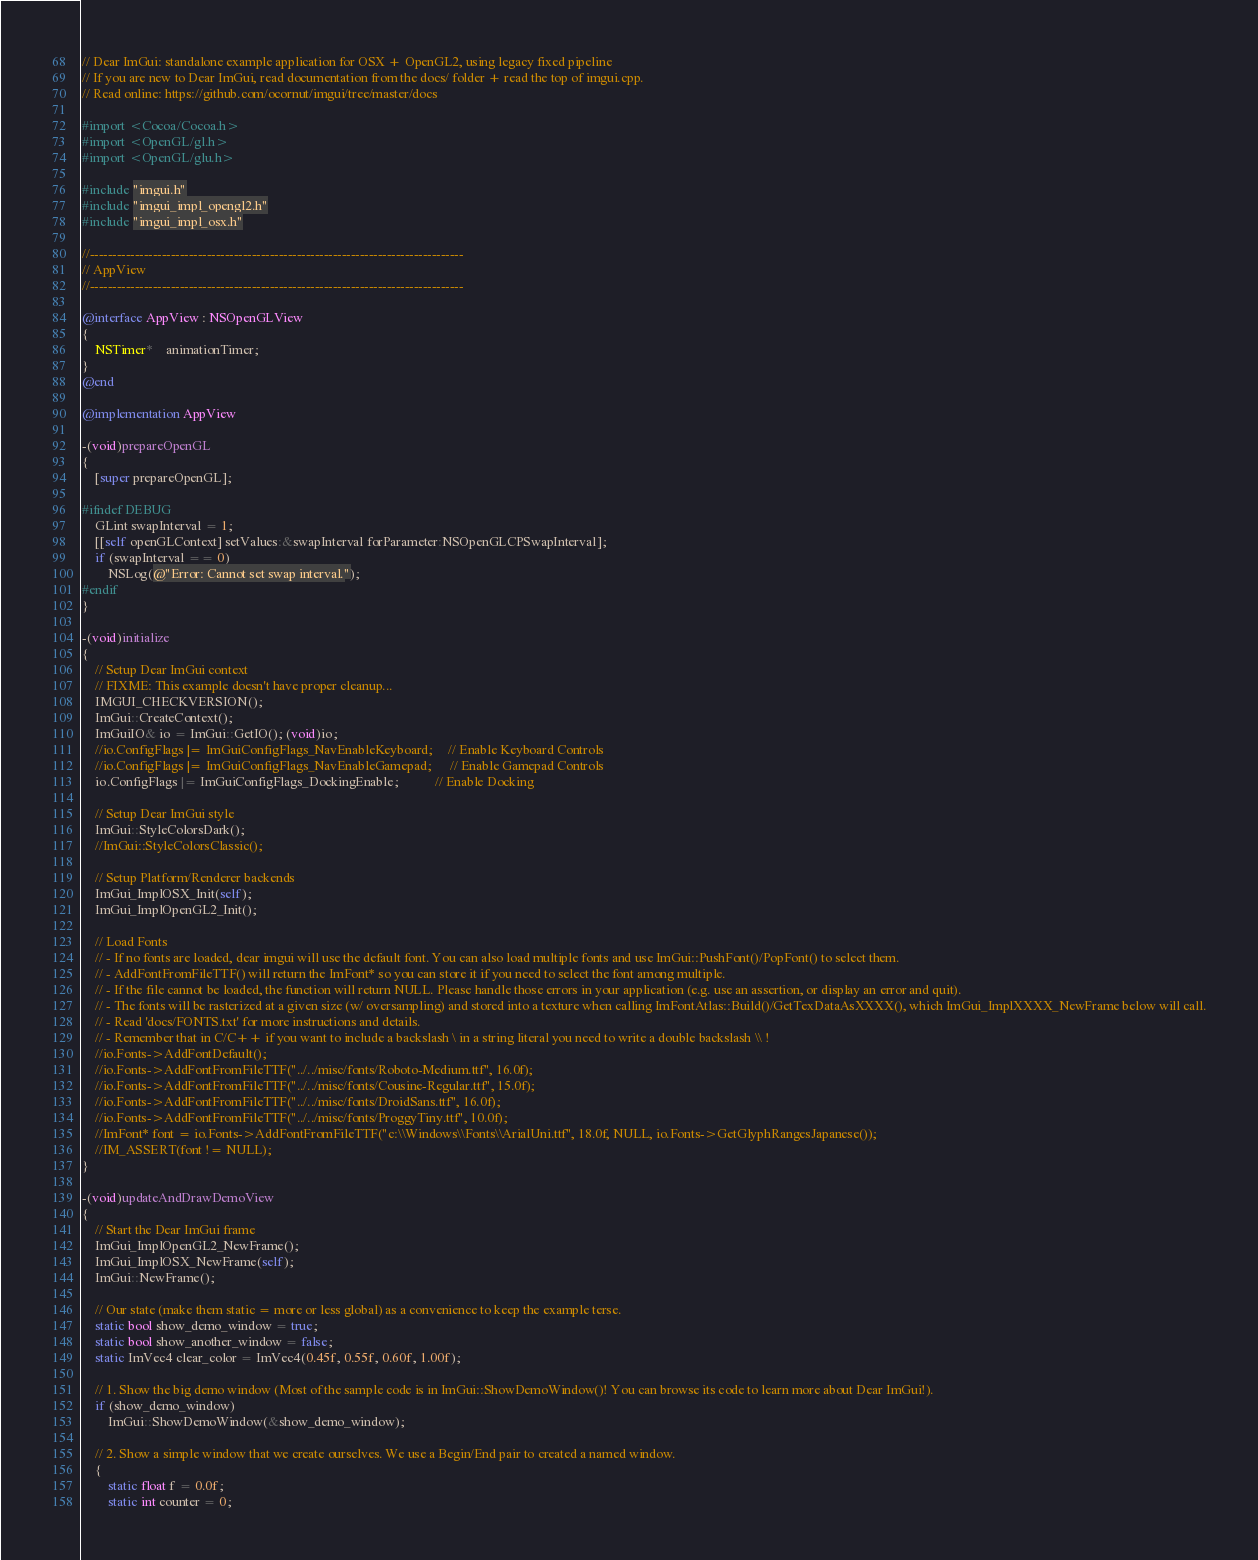<code> <loc_0><loc_0><loc_500><loc_500><_ObjectiveC_>// Dear ImGui: standalone example application for OSX + OpenGL2, using legacy fixed pipeline
// If you are new to Dear ImGui, read documentation from the docs/ folder + read the top of imgui.cpp.
// Read online: https://github.com/ocornut/imgui/tree/master/docs

#import <Cocoa/Cocoa.h>
#import <OpenGL/gl.h>
#import <OpenGL/glu.h>

#include "imgui.h"
#include "imgui_impl_opengl2.h"
#include "imgui_impl_osx.h"

//-----------------------------------------------------------------------------------
// AppView
//-----------------------------------------------------------------------------------

@interface AppView : NSOpenGLView
{
    NSTimer*    animationTimer;
}
@end

@implementation AppView

-(void)prepareOpenGL
{
    [super prepareOpenGL];

#ifndef DEBUG
    GLint swapInterval = 1;
    [[self openGLContext] setValues:&swapInterval forParameter:NSOpenGLCPSwapInterval];
    if (swapInterval == 0)
        NSLog(@"Error: Cannot set swap interval.");
#endif
}

-(void)initialize
{
    // Setup Dear ImGui context
    // FIXME: This example doesn't have proper cleanup...
    IMGUI_CHECKVERSION();
    ImGui::CreateContext();
    ImGuiIO& io = ImGui::GetIO(); (void)io;
    //io.ConfigFlags |= ImGuiConfigFlags_NavEnableKeyboard;     // Enable Keyboard Controls
    //io.ConfigFlags |= ImGuiConfigFlags_NavEnableGamepad;      // Enable Gamepad Controls
    io.ConfigFlags |= ImGuiConfigFlags_DockingEnable;           // Enable Docking

    // Setup Dear ImGui style
    ImGui::StyleColorsDark();
    //ImGui::StyleColorsClassic();

    // Setup Platform/Renderer backends
    ImGui_ImplOSX_Init(self);
    ImGui_ImplOpenGL2_Init();

    // Load Fonts
    // - If no fonts are loaded, dear imgui will use the default font. You can also load multiple fonts and use ImGui::PushFont()/PopFont() to select them.
    // - AddFontFromFileTTF() will return the ImFont* so you can store it if you need to select the font among multiple.
    // - If the file cannot be loaded, the function will return NULL. Please handle those errors in your application (e.g. use an assertion, or display an error and quit).
    // - The fonts will be rasterized at a given size (w/ oversampling) and stored into a texture when calling ImFontAtlas::Build()/GetTexDataAsXXXX(), which ImGui_ImplXXXX_NewFrame below will call.
    // - Read 'docs/FONTS.txt' for more instructions and details.
    // - Remember that in C/C++ if you want to include a backslash \ in a string literal you need to write a double backslash \\ !
    //io.Fonts->AddFontDefault();
    //io.Fonts->AddFontFromFileTTF("../../misc/fonts/Roboto-Medium.ttf", 16.0f);
    //io.Fonts->AddFontFromFileTTF("../../misc/fonts/Cousine-Regular.ttf", 15.0f);
    //io.Fonts->AddFontFromFileTTF("../../misc/fonts/DroidSans.ttf", 16.0f);
    //io.Fonts->AddFontFromFileTTF("../../misc/fonts/ProggyTiny.ttf", 10.0f);
    //ImFont* font = io.Fonts->AddFontFromFileTTF("c:\\Windows\\Fonts\\ArialUni.ttf", 18.0f, NULL, io.Fonts->GetGlyphRangesJapanese());
    //IM_ASSERT(font != NULL);
}

-(void)updateAndDrawDemoView
{
    // Start the Dear ImGui frame
    ImGui_ImplOpenGL2_NewFrame();
    ImGui_ImplOSX_NewFrame(self);
    ImGui::NewFrame();

    // Our state (make them static = more or less global) as a convenience to keep the example terse.
    static bool show_demo_window = true;
    static bool show_another_window = false;
    static ImVec4 clear_color = ImVec4(0.45f, 0.55f, 0.60f, 1.00f);

    // 1. Show the big demo window (Most of the sample code is in ImGui::ShowDemoWindow()! You can browse its code to learn more about Dear ImGui!).
    if (show_demo_window)
        ImGui::ShowDemoWindow(&show_demo_window);

    // 2. Show a simple window that we create ourselves. We use a Begin/End pair to created a named window.
    {
        static float f = 0.0f;
        static int counter = 0;
</code> 